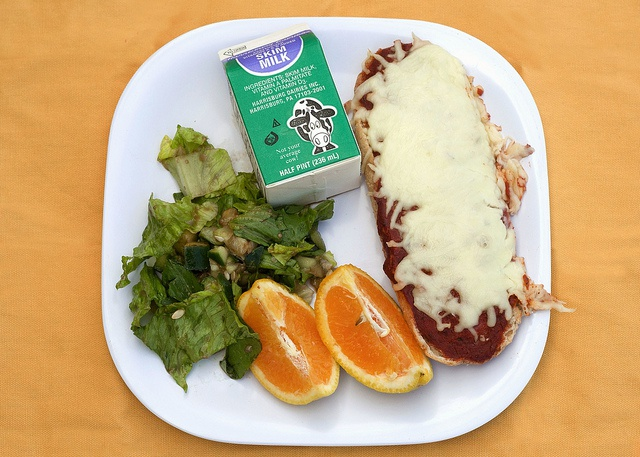Describe the objects in this image and their specific colors. I can see dining table in orange, lightgray, olive, beige, and darkgray tones, hot dog in orange, beige, maroon, and tan tones, orange in orange, red, and tan tones, and orange in orange, tan, and red tones in this image. 